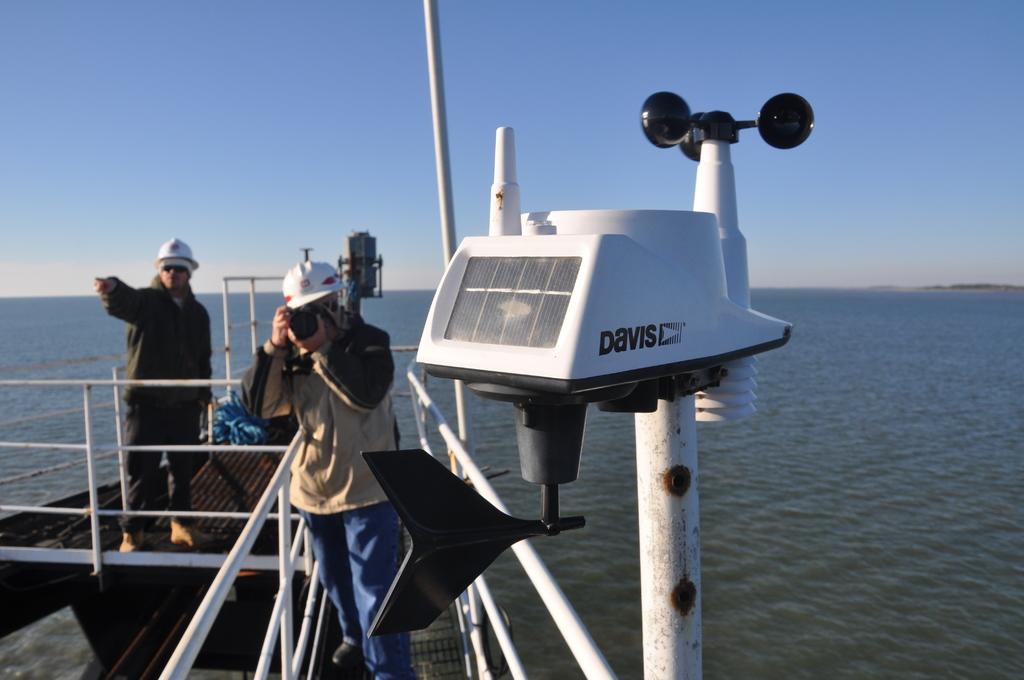What is printed on the light?
Give a very brief answer. Davis. 